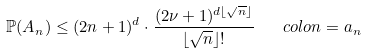<formula> <loc_0><loc_0><loc_500><loc_500>\mathbb { P } ( A _ { n } ) \leq ( 2 n + 1 ) ^ { d } \cdot \frac { ( 2 \nu + 1 ) ^ { d \lfloor \sqrt { n } \rfloor } } { \lfloor \sqrt { n } \rfloor ! } \ \ \ c o l o n = a _ { n }</formula> 